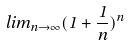Convert formula to latex. <formula><loc_0><loc_0><loc_500><loc_500>l i m _ { n \rightarrow \infty } ( 1 + \frac { 1 } { n } ) ^ { n }</formula> 